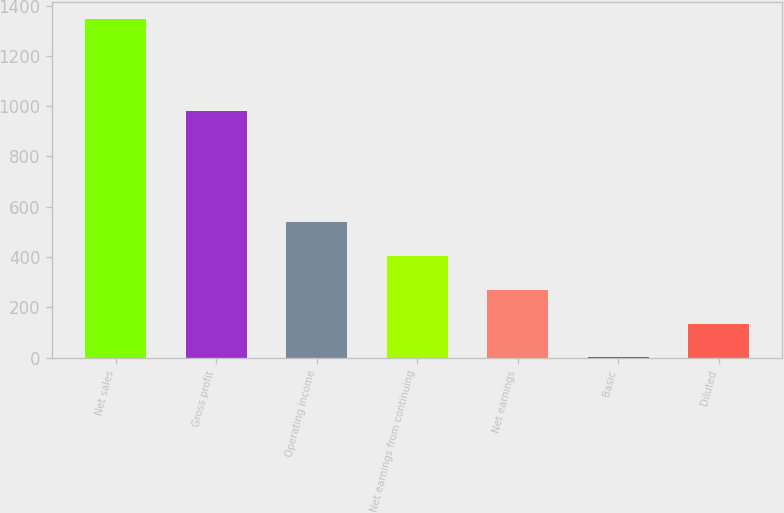Convert chart. <chart><loc_0><loc_0><loc_500><loc_500><bar_chart><fcel>Net sales<fcel>Gross profit<fcel>Operating income<fcel>Net earnings from continuing<fcel>Net earnings<fcel>Basic<fcel>Diluted<nl><fcel>1346.6<fcel>982.5<fcel>538.86<fcel>404.23<fcel>269.6<fcel>0.34<fcel>134.97<nl></chart> 